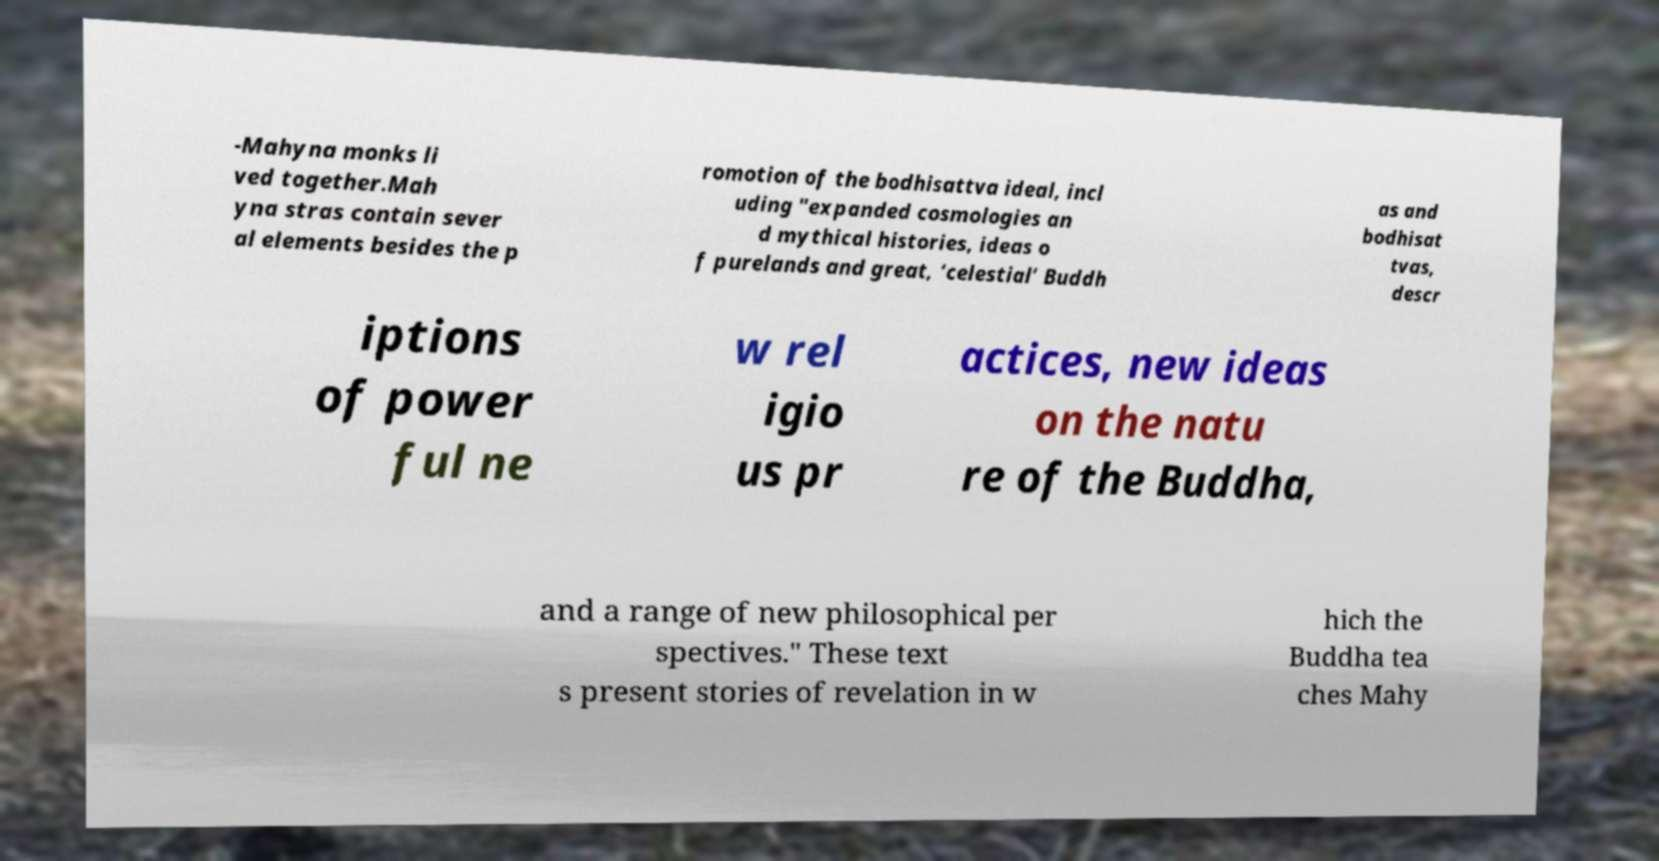For documentation purposes, I need the text within this image transcribed. Could you provide that? -Mahyna monks li ved together.Mah yna stras contain sever al elements besides the p romotion of the bodhisattva ideal, incl uding "expanded cosmologies an d mythical histories, ideas o f purelands and great, ‘celestial’ Buddh as and bodhisat tvas, descr iptions of power ful ne w rel igio us pr actices, new ideas on the natu re of the Buddha, and a range of new philosophical per spectives." These text s present stories of revelation in w hich the Buddha tea ches Mahy 